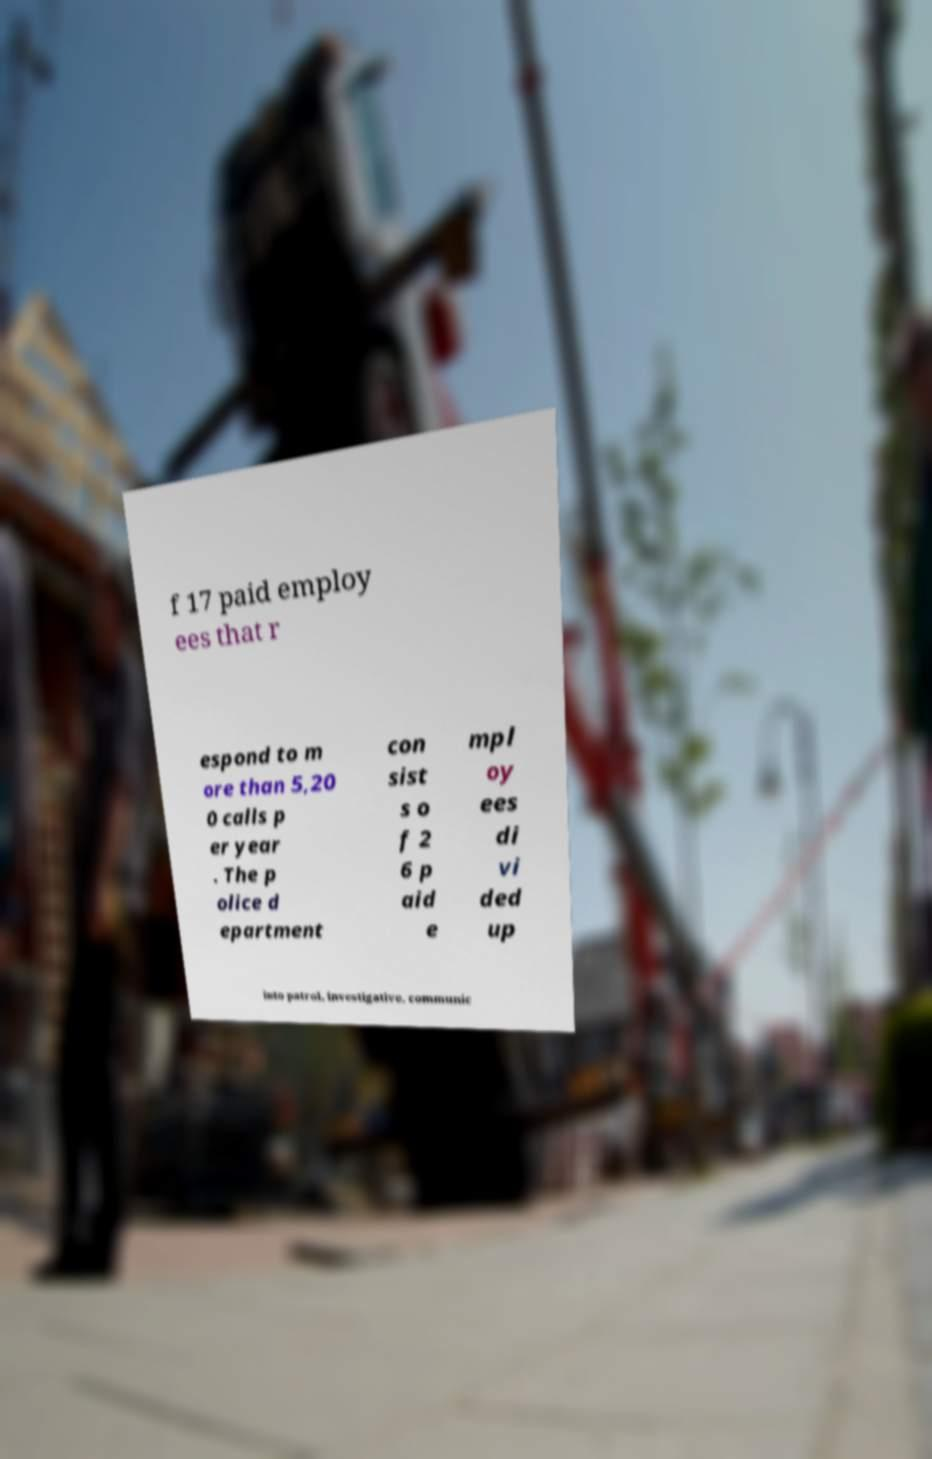There's text embedded in this image that I need extracted. Can you transcribe it verbatim? f 17 paid employ ees that r espond to m ore than 5,20 0 calls p er year . The p olice d epartment con sist s o f 2 6 p aid e mpl oy ees di vi ded up into patrol, investigative, communic 